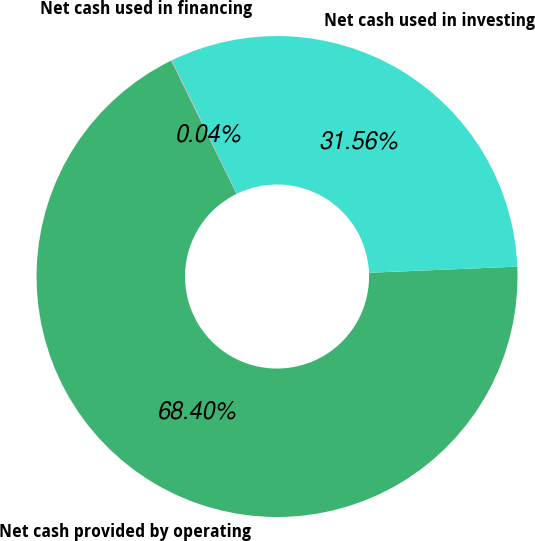Convert chart. <chart><loc_0><loc_0><loc_500><loc_500><pie_chart><fcel>Net cash provided by operating<fcel>Net cash used in investing<fcel>Net cash used in financing<nl><fcel>68.41%<fcel>31.56%<fcel>0.04%<nl></chart> 